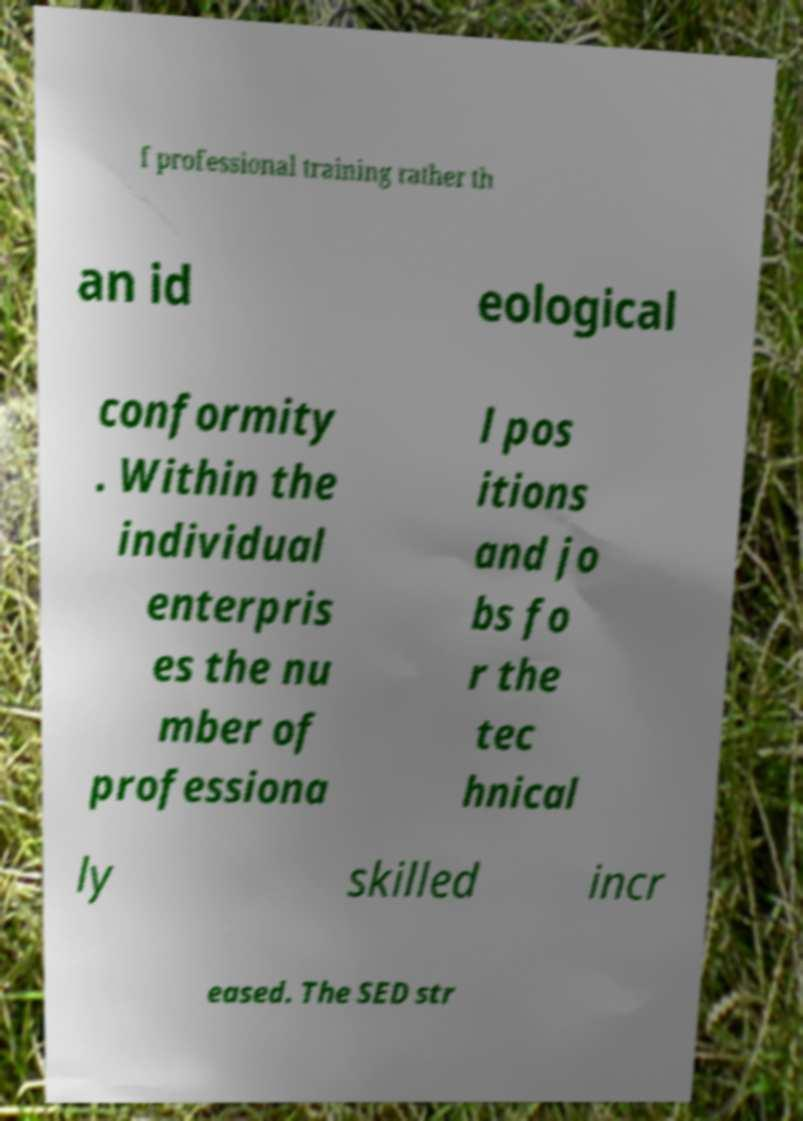Please read and relay the text visible in this image. What does it say? f professional training rather th an id eological conformity . Within the individual enterpris es the nu mber of professiona l pos itions and jo bs fo r the tec hnical ly skilled incr eased. The SED str 